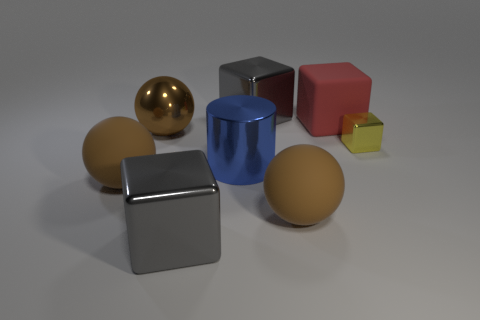Subtract all cyan cylinders. Subtract all yellow spheres. How many cylinders are left? 1 Add 1 metal blocks. How many objects exist? 9 Subtract all cylinders. How many objects are left? 7 Add 5 red matte cubes. How many red matte cubes are left? 6 Add 6 big brown rubber spheres. How many big brown rubber spheres exist? 8 Subtract 0 gray cylinders. How many objects are left? 8 Subtract all large gray things. Subtract all large red cubes. How many objects are left? 5 